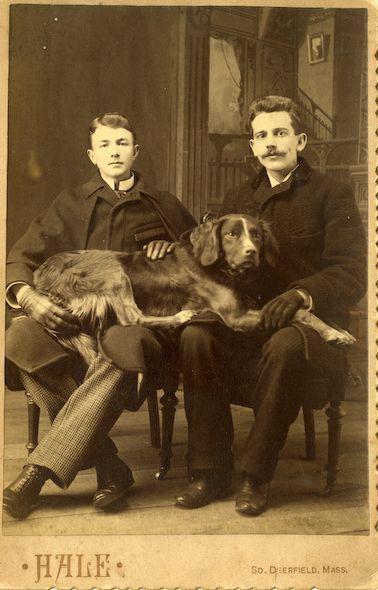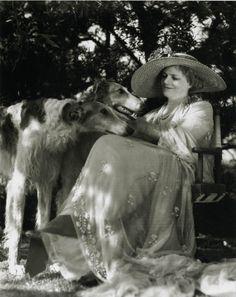The first image is the image on the left, the second image is the image on the right. Analyze the images presented: Is the assertion "There are three people and three dogs." valid? Answer yes or no. Yes. 